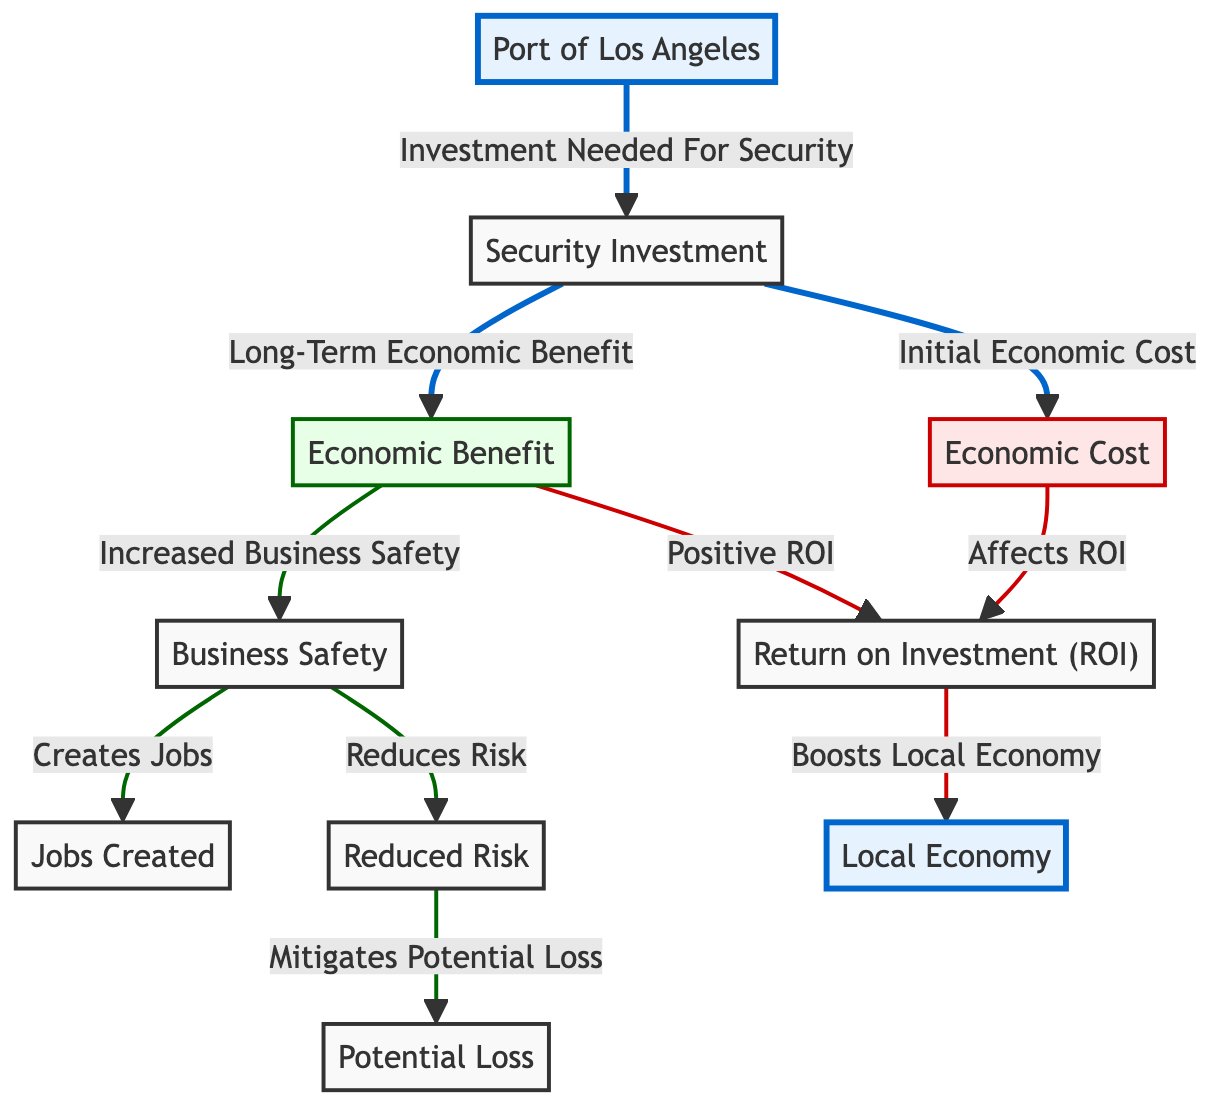What is the primary investment needed for security? The diagram shows that the primary investment needed is labeled as "Security Investment". This node is directly connected to the "Port of Los Angeles" node with the phrase "Investment Needed For Security".
Answer: Security Investment How many economic benefits are listed in the diagram? The diagram has three economic benefits listed: "Increased Business Safety", "Positive ROI", and "Jobs Created". This count can be derived by identifying each benefit node branching from the "Economic Benefit" node.
Answer: Three What does reduced risk mitigate? According to the diagram, "Reduced Risk" leads to "Mitigates Potential Loss". This connection indicates that the reduced risk helps in lessening potential financial or operational losses.
Answer: Potential Loss What affects the ROI? The diagram clearly states that "Initial Economic Cost" affects the "Return on Investment (ROI)", indicated by the arrow connecting these two nodes. Therefore, the initial costs have a direct impact on the ROI calculation.
Answer: Initial Economic Cost Which node directly follows "Increased Business Safety"? The diagram shows that "Increased Business Safety" leads directly to two connected nodes: "Creates Jobs" and "Reduces Risk". Therefore, these two nodes are the ones that follow "Increased Business Safety".
Answer: Creates Jobs, Reduces Risk What is the final outcome of a positive ROI? The diagram indicates that a positive ROI "Boosts Local Economy", showing a direct relationship between these two concepts. Thus, the final outcome in this context is the boost to the local economy resulting from a positive ROI.
Answer: Boosts Local Economy What type of diagram is this? The diagram is specifically a "Social Science Diagram", which focuses on the relationships between investments in security and their economic impacts on the port and surrounding businesses. This is indicated in the title and layout focusing on social and economic factors.
Answer: Social Science Diagram How many nodes are connected to "Economic Benefit"? The diagram shows that four nodes are connected to the "Economic Benefit" node: "Increased Business Safety", "Positive ROI", "Jobs Created", and "Reduces Risk". Counting these connections gives us the total.
Answer: Four 